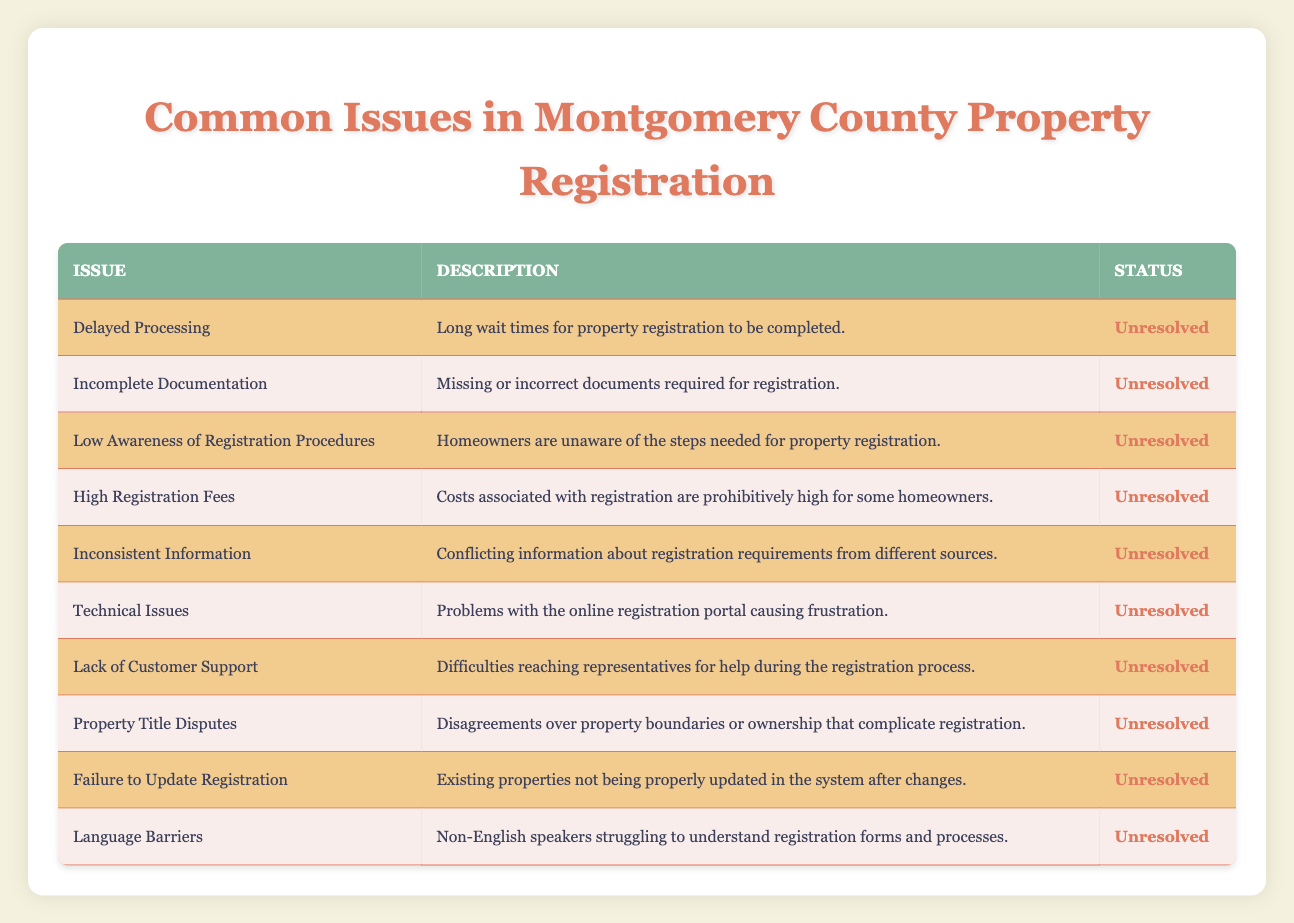What is the issue related to long wait times in property registration? The table indicates that "Delayed Processing" is the issue associated with long wait times for property registration to be completed.
Answer: Delayed Processing How many issues are classified as unresolved? The table lists ten issues, and all of them have a status marked as unresolved. Therefore, the total count is ten.
Answer: 10 Is there a specific issue regarding customer support during the registration process? Yes, according to the table, "Lack of Customer Support" is described as difficulties reaching representatives for help during the registration process.
Answer: Yes What are the two issues related to information discrepancies? The issues related to information discrepancies include "Incomplete Documentation" and "Inconsistent Information," as both pertain to problems with the correctness of information needed for registration.
Answer: Incomplete Documentation, Inconsistent Information If we sum the issues related to financial aspects and technical problems, how many total issues do we have? The issues related to financial aspects include "High Registration Fees," while the technical problem is "Technical Issues." Adding these two issues gives us a total of two financial and technical issues combined.
Answer: 2 Are there any issues that specifically mention language challenges? Yes, "Language Barriers" refers to the challenges non-English speakers face in understanding registration forms and processes, indicating that language challenges are indeed an issue.
Answer: Yes Which issue is concerned with property ownership disputes? The issue related to property ownership disputes is "Property Title Disputes," as it specifically mentions disagreements over property boundaries or ownership that complicate registration.
Answer: Property Title Disputes What is the description of the issue regarding homeowners’ knowledge of registration procedures? The issue titled "Low Awareness of Registration Procedures" describes homeowners being unaware of the steps needed for property registration.
Answer: Homeowners are unaware of the steps needed for property registration How many issues are solely related to registration updates? Among the listed issues, only "Failure to Update Registration" specifically pertains to the challenge of properly updating existing properties in the system. Thus, there is one issue related to registration updates.
Answer: 1 Is there a terminology related to waiting times for property registration? The terminology related to waiting times is captured under "Delayed Processing," which specifically refers to the impact of lengthy wait times on registration completion.
Answer: Yes 